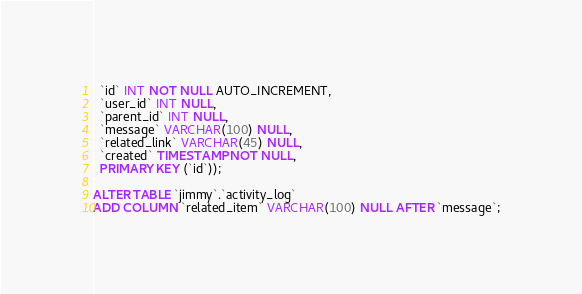<code> <loc_0><loc_0><loc_500><loc_500><_SQL_>  `id` INT NOT NULL AUTO_INCREMENT,
  `user_id` INT NULL,
  `parent_id` INT NULL,
  `message` VARCHAR(100) NULL,
  `related_link` VARCHAR(45) NULL,
  `created` TIMESTAMP NOT NULL,
  PRIMARY KEY (`id`));

ALTER TABLE `jimmy`.`activity_log` 
ADD COLUMN `related_item` VARCHAR(100) NULL AFTER `message`;

</code> 